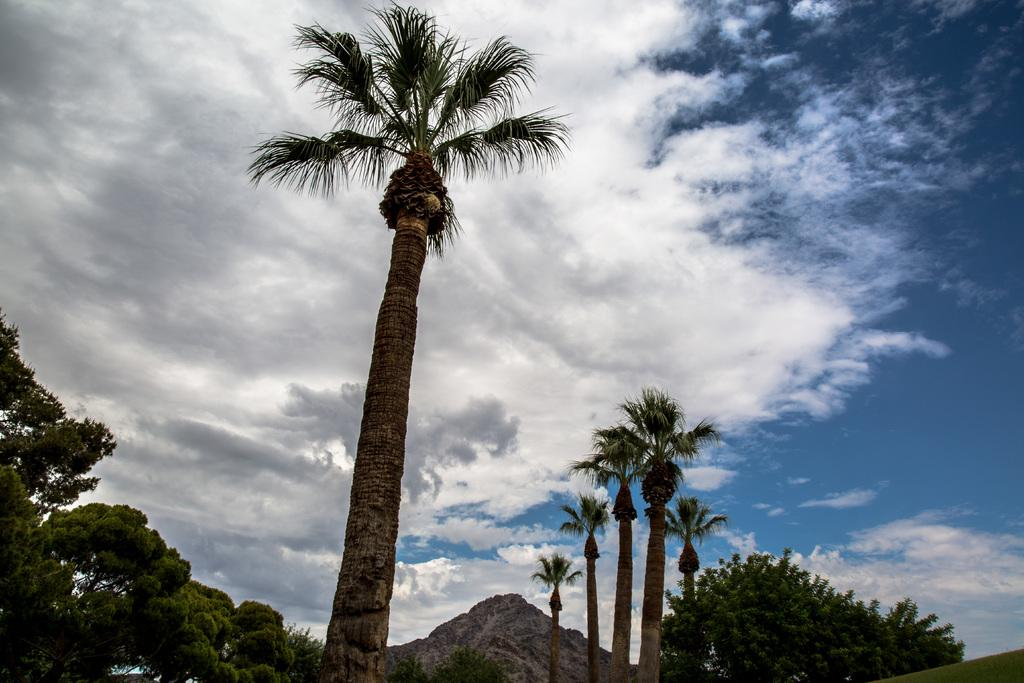What is the main subject in the middle of the image? There is a tall tree in the middle of the image. What else can be seen in the background of the image? There are other trees in the background of the image. What other object is located in the middle of the image? There is a big rock in the middle of the image. What is visible at the top of the image? The sky is visible at the top of the image. What can be observed in the sky? Clouds are present in the sky. What type of whip can be seen cracking in the image? There is no whip present in the image. What story is being told by the trees in the image? The trees in the image are not telling a story; they are simply depicted as part of the natural landscape. 